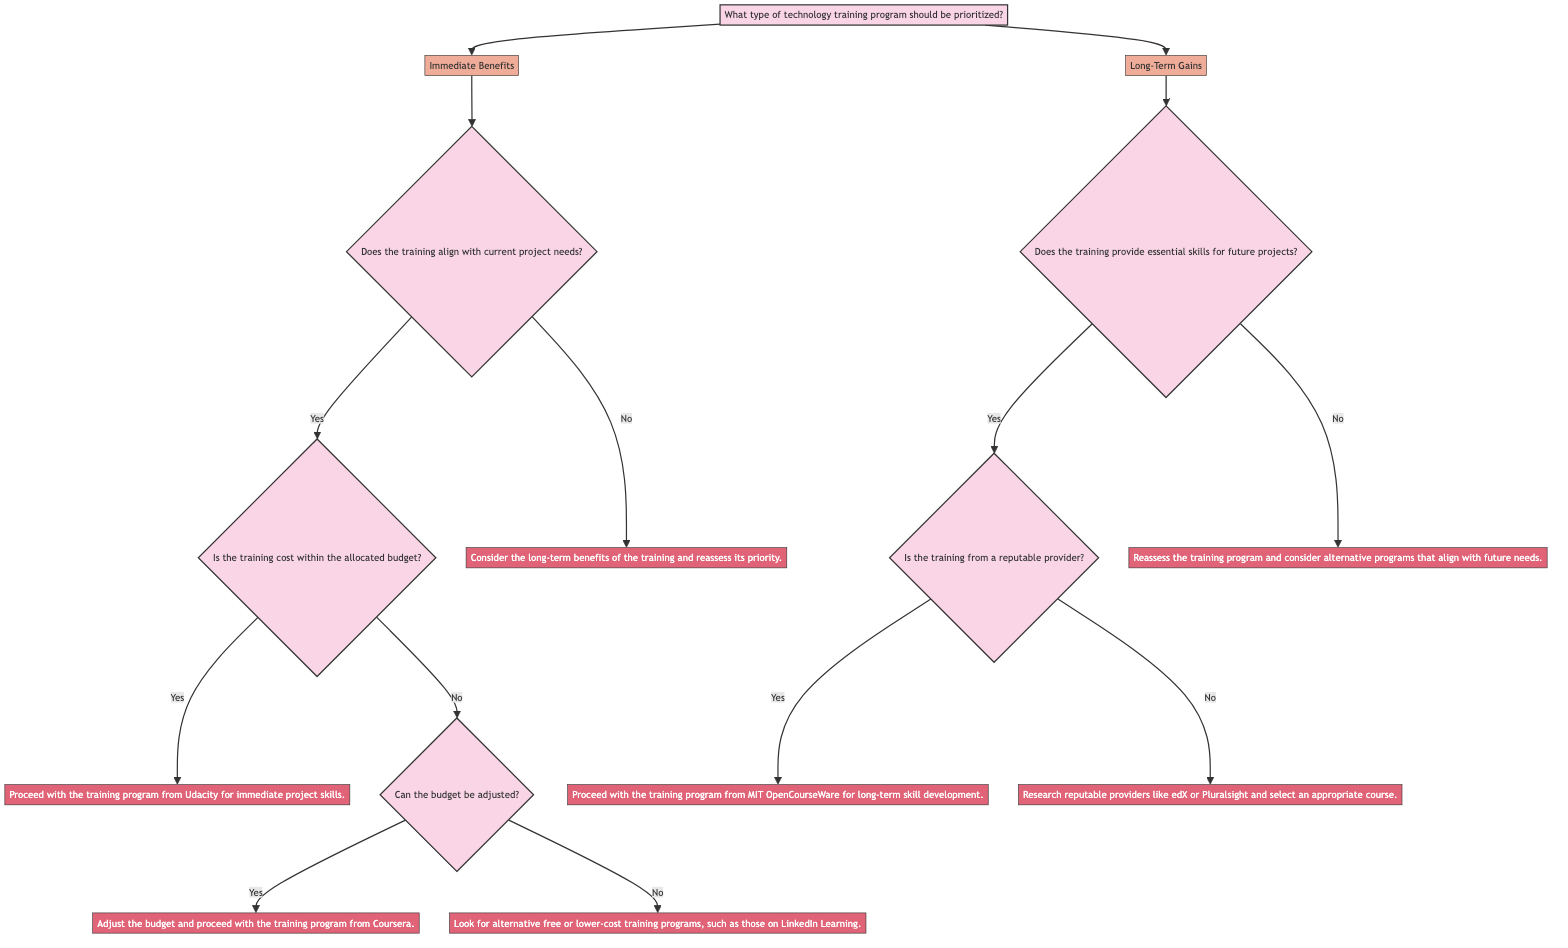What type of training program is the first option? The first option listed in the decision tree under the main question is "Immediate Benefits." This is directly shown as one of the branches from the initial node.
Answer: Immediate Benefits How many questions are in the "Immediate Benefits" path? Starting from "Immediate Benefits," there are three questions: "Does the training align with current project needs?", "Is the training cost within the allocated budget?", and "Can the budget be adjusted?". Counting these gives a total of three questions along this path.
Answer: 3 What happens if the training cost exceeds the allocated budget? If the training cost is not within the budget (which is indicated by a "No" response to the question "Is the training cost within the allocated budget?"), the next question is "Can the budget be adjusted?". If this question is answered with "Yes," it leads to proceeding with the training from Coursera. If answered "No," it directs to looking for free or lower-cost alternatives.
Answer: Look for alternative free or lower-cost training programs, such as those on LinkedIn Learning What is the next action after confirming the training aligns with project needs and the cost is within the budget? If the training aligns with current project needs and is within the budget, the action taken is to proceed with the training program from Udacity for immediate project skills. This is indicated in the diagram as the result of answering both initial questions positively.
Answer: Proceed with the training program from Udacity for immediate project skills What should be done if the training is not from a reputable provider? If the training is not from a reputable provider (indicated by a "No" response to "Is the training from a reputable provider?"), it suggests researching reputable providers like edX or Pluralsight to select an appropriate course. This indicates a strategic step to ensure quality in training.
Answer: Research reputable providers like edX or Pluralsight and select an appropriate course What is the outcome if the training does not provide essential skills for future projects? If the training does not provide essential skills for future projects (indicated by a "No" response to "Does the training provide essential skills for future projects?"), the action is to reassess the training program and consider alternatives that align with future needs, as stated in the decision-making flow.
Answer: Reassess the training program and consider alternative programs that align with future needs How many actions are there after the question regarding essential skills for future projects? Upon reaching the question about essential skills, there are two possible actions based on the responses: proceed with a reputable training provider or reassess the training program. This indicates there are two distinct actions stemming from this question.
Answer: 2 What is the immediate follow-up after answering "No" to "Does the training align with current project needs?" If the answer is "No" to "Does the training align with current project needs?", the immediate follow-up is to "Consider the long-term benefits of the training and reassess its priority." This showcases an alternate route that considers long-term strategy.
Answer: Consider the long-term benefits of the training and reassess its priority 